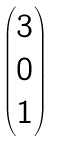<formula> <loc_0><loc_0><loc_500><loc_500>\begin{pmatrix} 3 \\ 0 \\ 1 \end{pmatrix}</formula> 